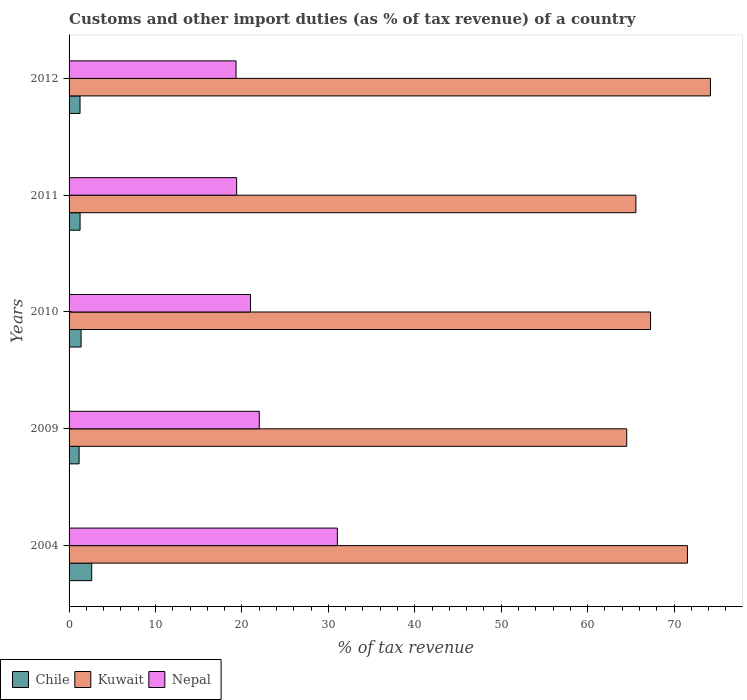How many groups of bars are there?
Your answer should be compact. 5. Are the number of bars per tick equal to the number of legend labels?
Give a very brief answer. Yes. Are the number of bars on each tick of the Y-axis equal?
Offer a terse response. Yes. What is the label of the 1st group of bars from the top?
Offer a very short reply. 2012. In how many cases, is the number of bars for a given year not equal to the number of legend labels?
Provide a short and direct response. 0. What is the percentage of tax revenue from customs in Chile in 2004?
Keep it short and to the point. 2.62. Across all years, what is the maximum percentage of tax revenue from customs in Kuwait?
Provide a short and direct response. 74.21. Across all years, what is the minimum percentage of tax revenue from customs in Chile?
Provide a short and direct response. 1.16. What is the total percentage of tax revenue from customs in Nepal in the graph?
Keep it short and to the point. 112.76. What is the difference between the percentage of tax revenue from customs in Kuwait in 2011 and that in 2012?
Offer a terse response. -8.62. What is the difference between the percentage of tax revenue from customs in Chile in 2004 and the percentage of tax revenue from customs in Nepal in 2009?
Your answer should be very brief. -19.39. What is the average percentage of tax revenue from customs in Chile per year?
Provide a short and direct response. 1.54. In the year 2012, what is the difference between the percentage of tax revenue from customs in Kuwait and percentage of tax revenue from customs in Chile?
Offer a terse response. 72.94. What is the ratio of the percentage of tax revenue from customs in Chile in 2011 to that in 2012?
Your answer should be very brief. 1. Is the percentage of tax revenue from customs in Kuwait in 2010 less than that in 2012?
Offer a very short reply. Yes. Is the difference between the percentage of tax revenue from customs in Kuwait in 2009 and 2011 greater than the difference between the percentage of tax revenue from customs in Chile in 2009 and 2011?
Offer a very short reply. No. What is the difference between the highest and the second highest percentage of tax revenue from customs in Nepal?
Your response must be concise. 9.03. What is the difference between the highest and the lowest percentage of tax revenue from customs in Chile?
Your answer should be very brief. 1.46. What does the 2nd bar from the top in 2009 represents?
Provide a succinct answer. Kuwait. What does the 2nd bar from the bottom in 2011 represents?
Offer a very short reply. Kuwait. Is it the case that in every year, the sum of the percentage of tax revenue from customs in Kuwait and percentage of tax revenue from customs in Nepal is greater than the percentage of tax revenue from customs in Chile?
Ensure brevity in your answer.  Yes. Are all the bars in the graph horizontal?
Your answer should be very brief. Yes. How many years are there in the graph?
Provide a short and direct response. 5. What is the difference between two consecutive major ticks on the X-axis?
Provide a short and direct response. 10. Does the graph contain any zero values?
Provide a succinct answer. No. Does the graph contain grids?
Ensure brevity in your answer.  No. How many legend labels are there?
Offer a terse response. 3. What is the title of the graph?
Your answer should be compact. Customs and other import duties (as % of tax revenue) of a country. Does "Gabon" appear as one of the legend labels in the graph?
Ensure brevity in your answer.  No. What is the label or title of the X-axis?
Offer a very short reply. % of tax revenue. What is the % of tax revenue of Chile in 2004?
Give a very brief answer. 2.62. What is the % of tax revenue of Kuwait in 2004?
Give a very brief answer. 71.55. What is the % of tax revenue of Nepal in 2004?
Provide a succinct answer. 31.04. What is the % of tax revenue of Chile in 2009?
Offer a very short reply. 1.16. What is the % of tax revenue in Kuwait in 2009?
Give a very brief answer. 64.53. What is the % of tax revenue of Nepal in 2009?
Make the answer very short. 22.01. What is the % of tax revenue of Chile in 2010?
Make the answer very short. 1.39. What is the % of tax revenue of Kuwait in 2010?
Offer a terse response. 67.28. What is the % of tax revenue in Nepal in 2010?
Offer a very short reply. 20.99. What is the % of tax revenue of Chile in 2011?
Ensure brevity in your answer.  1.27. What is the % of tax revenue in Kuwait in 2011?
Your answer should be very brief. 65.59. What is the % of tax revenue of Nepal in 2011?
Your answer should be compact. 19.39. What is the % of tax revenue in Chile in 2012?
Your answer should be compact. 1.27. What is the % of tax revenue of Kuwait in 2012?
Keep it short and to the point. 74.21. What is the % of tax revenue of Nepal in 2012?
Provide a succinct answer. 19.32. Across all years, what is the maximum % of tax revenue of Chile?
Offer a very short reply. 2.62. Across all years, what is the maximum % of tax revenue of Kuwait?
Provide a short and direct response. 74.21. Across all years, what is the maximum % of tax revenue in Nepal?
Make the answer very short. 31.04. Across all years, what is the minimum % of tax revenue of Chile?
Give a very brief answer. 1.16. Across all years, what is the minimum % of tax revenue of Kuwait?
Your answer should be compact. 64.53. Across all years, what is the minimum % of tax revenue of Nepal?
Provide a short and direct response. 19.32. What is the total % of tax revenue in Chile in the graph?
Ensure brevity in your answer.  7.71. What is the total % of tax revenue in Kuwait in the graph?
Offer a very short reply. 343.16. What is the total % of tax revenue in Nepal in the graph?
Ensure brevity in your answer.  112.76. What is the difference between the % of tax revenue of Chile in 2004 and that in 2009?
Your answer should be very brief. 1.46. What is the difference between the % of tax revenue in Kuwait in 2004 and that in 2009?
Make the answer very short. 7.02. What is the difference between the % of tax revenue in Nepal in 2004 and that in 2009?
Give a very brief answer. 9.03. What is the difference between the % of tax revenue in Chile in 2004 and that in 2010?
Provide a short and direct response. 1.23. What is the difference between the % of tax revenue in Kuwait in 2004 and that in 2010?
Provide a succinct answer. 4.27. What is the difference between the % of tax revenue of Nepal in 2004 and that in 2010?
Keep it short and to the point. 10.05. What is the difference between the % of tax revenue in Chile in 2004 and that in 2011?
Keep it short and to the point. 1.35. What is the difference between the % of tax revenue of Kuwait in 2004 and that in 2011?
Ensure brevity in your answer.  5.96. What is the difference between the % of tax revenue in Nepal in 2004 and that in 2011?
Give a very brief answer. 11.65. What is the difference between the % of tax revenue in Chile in 2004 and that in 2012?
Provide a succinct answer. 1.35. What is the difference between the % of tax revenue in Kuwait in 2004 and that in 2012?
Make the answer very short. -2.66. What is the difference between the % of tax revenue of Nepal in 2004 and that in 2012?
Keep it short and to the point. 11.72. What is the difference between the % of tax revenue in Chile in 2009 and that in 2010?
Your answer should be compact. -0.23. What is the difference between the % of tax revenue of Kuwait in 2009 and that in 2010?
Provide a short and direct response. -2.76. What is the difference between the % of tax revenue in Nepal in 2009 and that in 2010?
Your answer should be very brief. 1.02. What is the difference between the % of tax revenue of Chile in 2009 and that in 2011?
Provide a succinct answer. -0.11. What is the difference between the % of tax revenue in Kuwait in 2009 and that in 2011?
Provide a succinct answer. -1.06. What is the difference between the % of tax revenue of Nepal in 2009 and that in 2011?
Keep it short and to the point. 2.62. What is the difference between the % of tax revenue in Chile in 2009 and that in 2012?
Offer a very short reply. -0.11. What is the difference between the % of tax revenue in Kuwait in 2009 and that in 2012?
Keep it short and to the point. -9.69. What is the difference between the % of tax revenue in Nepal in 2009 and that in 2012?
Offer a terse response. 2.69. What is the difference between the % of tax revenue of Chile in 2010 and that in 2011?
Offer a terse response. 0.12. What is the difference between the % of tax revenue in Kuwait in 2010 and that in 2011?
Provide a succinct answer. 1.7. What is the difference between the % of tax revenue in Nepal in 2010 and that in 2011?
Provide a succinct answer. 1.6. What is the difference between the % of tax revenue in Chile in 2010 and that in 2012?
Offer a terse response. 0.12. What is the difference between the % of tax revenue in Kuwait in 2010 and that in 2012?
Provide a succinct answer. -6.93. What is the difference between the % of tax revenue of Nepal in 2010 and that in 2012?
Provide a short and direct response. 1.67. What is the difference between the % of tax revenue in Chile in 2011 and that in 2012?
Offer a terse response. 0. What is the difference between the % of tax revenue in Kuwait in 2011 and that in 2012?
Your answer should be compact. -8.62. What is the difference between the % of tax revenue of Nepal in 2011 and that in 2012?
Provide a succinct answer. 0.07. What is the difference between the % of tax revenue in Chile in 2004 and the % of tax revenue in Kuwait in 2009?
Your answer should be very brief. -61.91. What is the difference between the % of tax revenue in Chile in 2004 and the % of tax revenue in Nepal in 2009?
Your response must be concise. -19.39. What is the difference between the % of tax revenue of Kuwait in 2004 and the % of tax revenue of Nepal in 2009?
Your response must be concise. 49.54. What is the difference between the % of tax revenue of Chile in 2004 and the % of tax revenue of Kuwait in 2010?
Ensure brevity in your answer.  -64.66. What is the difference between the % of tax revenue in Chile in 2004 and the % of tax revenue in Nepal in 2010?
Give a very brief answer. -18.37. What is the difference between the % of tax revenue of Kuwait in 2004 and the % of tax revenue of Nepal in 2010?
Offer a terse response. 50.56. What is the difference between the % of tax revenue in Chile in 2004 and the % of tax revenue in Kuwait in 2011?
Ensure brevity in your answer.  -62.97. What is the difference between the % of tax revenue of Chile in 2004 and the % of tax revenue of Nepal in 2011?
Keep it short and to the point. -16.77. What is the difference between the % of tax revenue of Kuwait in 2004 and the % of tax revenue of Nepal in 2011?
Make the answer very short. 52.16. What is the difference between the % of tax revenue in Chile in 2004 and the % of tax revenue in Kuwait in 2012?
Offer a terse response. -71.59. What is the difference between the % of tax revenue of Chile in 2004 and the % of tax revenue of Nepal in 2012?
Ensure brevity in your answer.  -16.7. What is the difference between the % of tax revenue of Kuwait in 2004 and the % of tax revenue of Nepal in 2012?
Provide a succinct answer. 52.23. What is the difference between the % of tax revenue of Chile in 2009 and the % of tax revenue of Kuwait in 2010?
Give a very brief answer. -66.12. What is the difference between the % of tax revenue in Chile in 2009 and the % of tax revenue in Nepal in 2010?
Make the answer very short. -19.83. What is the difference between the % of tax revenue in Kuwait in 2009 and the % of tax revenue in Nepal in 2010?
Offer a very short reply. 43.53. What is the difference between the % of tax revenue in Chile in 2009 and the % of tax revenue in Kuwait in 2011?
Offer a very short reply. -64.43. What is the difference between the % of tax revenue in Chile in 2009 and the % of tax revenue in Nepal in 2011?
Offer a very short reply. -18.23. What is the difference between the % of tax revenue of Kuwait in 2009 and the % of tax revenue of Nepal in 2011?
Give a very brief answer. 45.14. What is the difference between the % of tax revenue of Chile in 2009 and the % of tax revenue of Kuwait in 2012?
Your answer should be compact. -73.05. What is the difference between the % of tax revenue in Chile in 2009 and the % of tax revenue in Nepal in 2012?
Offer a very short reply. -18.16. What is the difference between the % of tax revenue in Kuwait in 2009 and the % of tax revenue in Nepal in 2012?
Your answer should be very brief. 45.21. What is the difference between the % of tax revenue in Chile in 2010 and the % of tax revenue in Kuwait in 2011?
Offer a terse response. -64.2. What is the difference between the % of tax revenue in Chile in 2010 and the % of tax revenue in Nepal in 2011?
Your response must be concise. -18. What is the difference between the % of tax revenue of Kuwait in 2010 and the % of tax revenue of Nepal in 2011?
Provide a succinct answer. 47.89. What is the difference between the % of tax revenue in Chile in 2010 and the % of tax revenue in Kuwait in 2012?
Provide a short and direct response. -72.82. What is the difference between the % of tax revenue in Chile in 2010 and the % of tax revenue in Nepal in 2012?
Your answer should be very brief. -17.93. What is the difference between the % of tax revenue of Kuwait in 2010 and the % of tax revenue of Nepal in 2012?
Provide a short and direct response. 47.96. What is the difference between the % of tax revenue in Chile in 2011 and the % of tax revenue in Kuwait in 2012?
Give a very brief answer. -72.94. What is the difference between the % of tax revenue in Chile in 2011 and the % of tax revenue in Nepal in 2012?
Your response must be concise. -18.05. What is the difference between the % of tax revenue of Kuwait in 2011 and the % of tax revenue of Nepal in 2012?
Offer a terse response. 46.27. What is the average % of tax revenue in Chile per year?
Your answer should be very brief. 1.54. What is the average % of tax revenue of Kuwait per year?
Ensure brevity in your answer.  68.63. What is the average % of tax revenue in Nepal per year?
Provide a succinct answer. 22.55. In the year 2004, what is the difference between the % of tax revenue in Chile and % of tax revenue in Kuwait?
Keep it short and to the point. -68.93. In the year 2004, what is the difference between the % of tax revenue of Chile and % of tax revenue of Nepal?
Ensure brevity in your answer.  -28.42. In the year 2004, what is the difference between the % of tax revenue of Kuwait and % of tax revenue of Nepal?
Keep it short and to the point. 40.51. In the year 2009, what is the difference between the % of tax revenue in Chile and % of tax revenue in Kuwait?
Offer a terse response. -63.37. In the year 2009, what is the difference between the % of tax revenue of Chile and % of tax revenue of Nepal?
Ensure brevity in your answer.  -20.85. In the year 2009, what is the difference between the % of tax revenue in Kuwait and % of tax revenue in Nepal?
Your answer should be compact. 42.52. In the year 2010, what is the difference between the % of tax revenue in Chile and % of tax revenue in Kuwait?
Ensure brevity in your answer.  -65.89. In the year 2010, what is the difference between the % of tax revenue in Chile and % of tax revenue in Nepal?
Ensure brevity in your answer.  -19.6. In the year 2010, what is the difference between the % of tax revenue of Kuwait and % of tax revenue of Nepal?
Keep it short and to the point. 46.29. In the year 2011, what is the difference between the % of tax revenue of Chile and % of tax revenue of Kuwait?
Make the answer very short. -64.32. In the year 2011, what is the difference between the % of tax revenue of Chile and % of tax revenue of Nepal?
Provide a short and direct response. -18.12. In the year 2011, what is the difference between the % of tax revenue in Kuwait and % of tax revenue in Nepal?
Offer a terse response. 46.2. In the year 2012, what is the difference between the % of tax revenue of Chile and % of tax revenue of Kuwait?
Offer a terse response. -72.94. In the year 2012, what is the difference between the % of tax revenue of Chile and % of tax revenue of Nepal?
Your response must be concise. -18.05. In the year 2012, what is the difference between the % of tax revenue of Kuwait and % of tax revenue of Nepal?
Offer a terse response. 54.89. What is the ratio of the % of tax revenue in Chile in 2004 to that in 2009?
Provide a short and direct response. 2.26. What is the ratio of the % of tax revenue in Kuwait in 2004 to that in 2009?
Make the answer very short. 1.11. What is the ratio of the % of tax revenue of Nepal in 2004 to that in 2009?
Make the answer very short. 1.41. What is the ratio of the % of tax revenue of Chile in 2004 to that in 2010?
Offer a terse response. 1.89. What is the ratio of the % of tax revenue in Kuwait in 2004 to that in 2010?
Your answer should be compact. 1.06. What is the ratio of the % of tax revenue in Nepal in 2004 to that in 2010?
Offer a terse response. 1.48. What is the ratio of the % of tax revenue of Chile in 2004 to that in 2011?
Give a very brief answer. 2.06. What is the ratio of the % of tax revenue in Kuwait in 2004 to that in 2011?
Your answer should be compact. 1.09. What is the ratio of the % of tax revenue in Nepal in 2004 to that in 2011?
Your answer should be very brief. 1.6. What is the ratio of the % of tax revenue of Chile in 2004 to that in 2012?
Your response must be concise. 2.07. What is the ratio of the % of tax revenue of Kuwait in 2004 to that in 2012?
Your answer should be very brief. 0.96. What is the ratio of the % of tax revenue in Nepal in 2004 to that in 2012?
Offer a terse response. 1.61. What is the ratio of the % of tax revenue in Chile in 2009 to that in 2010?
Keep it short and to the point. 0.83. What is the ratio of the % of tax revenue in Kuwait in 2009 to that in 2010?
Provide a succinct answer. 0.96. What is the ratio of the % of tax revenue of Nepal in 2009 to that in 2010?
Provide a succinct answer. 1.05. What is the ratio of the % of tax revenue in Chile in 2009 to that in 2011?
Offer a very short reply. 0.91. What is the ratio of the % of tax revenue of Kuwait in 2009 to that in 2011?
Your answer should be compact. 0.98. What is the ratio of the % of tax revenue of Nepal in 2009 to that in 2011?
Keep it short and to the point. 1.14. What is the ratio of the % of tax revenue of Chile in 2009 to that in 2012?
Your response must be concise. 0.92. What is the ratio of the % of tax revenue in Kuwait in 2009 to that in 2012?
Your response must be concise. 0.87. What is the ratio of the % of tax revenue in Nepal in 2009 to that in 2012?
Provide a succinct answer. 1.14. What is the ratio of the % of tax revenue in Chile in 2010 to that in 2011?
Make the answer very short. 1.09. What is the ratio of the % of tax revenue of Kuwait in 2010 to that in 2011?
Ensure brevity in your answer.  1.03. What is the ratio of the % of tax revenue in Nepal in 2010 to that in 2011?
Offer a terse response. 1.08. What is the ratio of the % of tax revenue of Chile in 2010 to that in 2012?
Offer a very short reply. 1.1. What is the ratio of the % of tax revenue of Kuwait in 2010 to that in 2012?
Offer a terse response. 0.91. What is the ratio of the % of tax revenue of Nepal in 2010 to that in 2012?
Make the answer very short. 1.09. What is the ratio of the % of tax revenue of Chile in 2011 to that in 2012?
Your response must be concise. 1. What is the ratio of the % of tax revenue in Kuwait in 2011 to that in 2012?
Provide a succinct answer. 0.88. What is the difference between the highest and the second highest % of tax revenue in Chile?
Offer a terse response. 1.23. What is the difference between the highest and the second highest % of tax revenue of Kuwait?
Provide a short and direct response. 2.66. What is the difference between the highest and the second highest % of tax revenue of Nepal?
Your answer should be compact. 9.03. What is the difference between the highest and the lowest % of tax revenue of Chile?
Your response must be concise. 1.46. What is the difference between the highest and the lowest % of tax revenue of Kuwait?
Make the answer very short. 9.69. What is the difference between the highest and the lowest % of tax revenue in Nepal?
Ensure brevity in your answer.  11.72. 